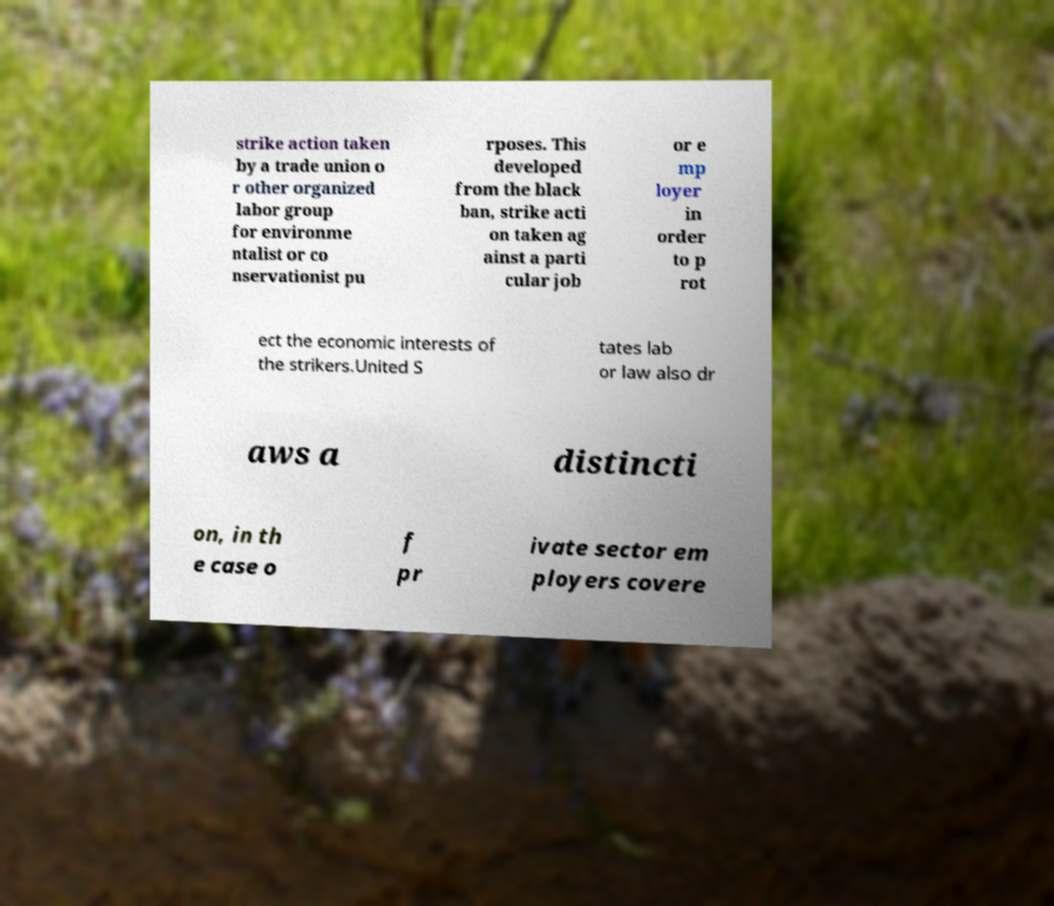I need the written content from this picture converted into text. Can you do that? strike action taken by a trade union o r other organized labor group for environme ntalist or co nservationist pu rposes. This developed from the black ban, strike acti on taken ag ainst a parti cular job or e mp loyer in order to p rot ect the economic interests of the strikers.United S tates lab or law also dr aws a distincti on, in th e case o f pr ivate sector em ployers covere 